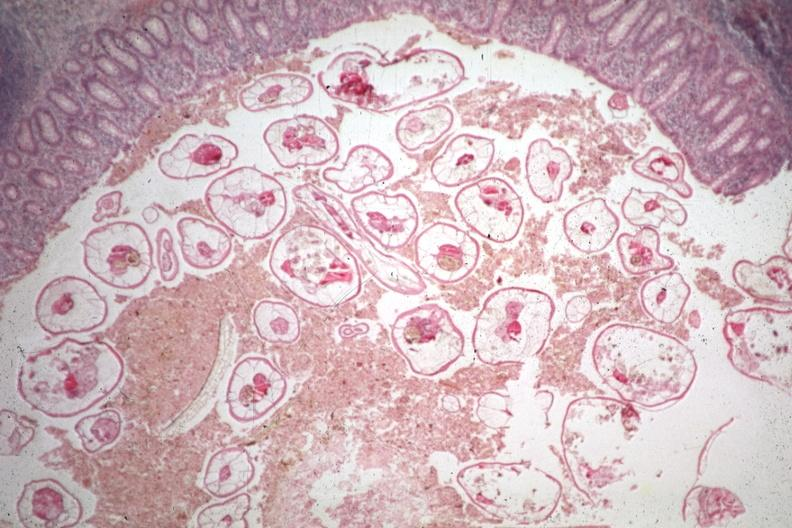does this image show typical excellent pinworm?
Answer the question using a single word or phrase. Yes 